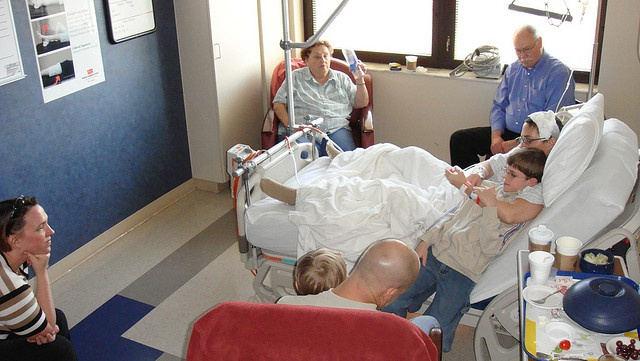Describe the objects in this image and their specific colors. I can see bed in darkgray, lightgray, and gray tones, chair in darkgray, brown, maroon, and salmon tones, people in darkgray, blue, and gray tones, people in darkgray, black, brown, and gray tones, and people in darkgray, gray, black, and brown tones in this image. 